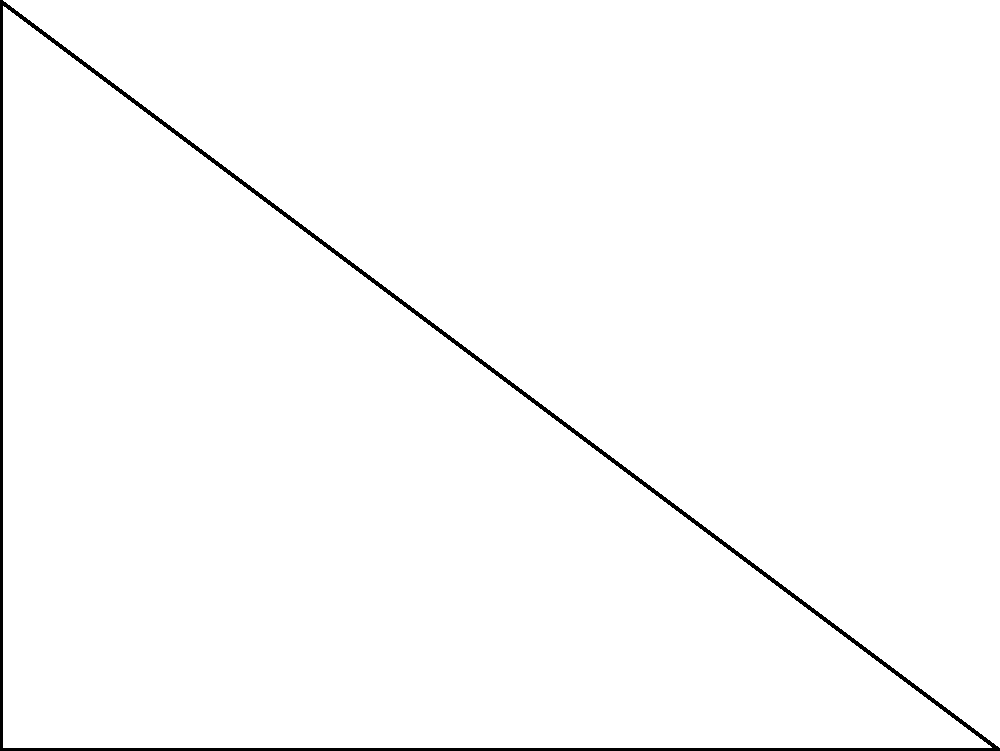In a screenplay about geometric patterns in Brazilian architecture, you need to describe a circular fountain inscribed within a triangular plaza. The plaza is shaped like a right-angled triangle with sides 6 meters and 8 meters. What is the radius of the circular fountain that perfectly fits within this triangular plaza? Let's approach this step-by-step:

1) In a right-angled triangle, let $a$ and $b$ be the lengths of the two perpendicular sides, and $c$ be the length of the hypotenuse.

2) Given: $a = 6$ m, $b = 8$ m

3) To find the hypotenuse $c$, we use the Pythagorean theorem:
   $c^2 = a^2 + b^2 = 6^2 + 8^2 = 36 + 64 = 100$
   $c = \sqrt{100} = 10$ m

4) The formula for the radius $r$ of an inscribed circle in a right-angled triangle is:
   $r = \frac{a + b - c}{2}$

5) Substituting our values:
   $r = \frac{6 + 8 - 10}{2} = \frac{4}{2} = 2$

Therefore, the radius of the circular fountain is 2 meters.
Answer: 2 meters 